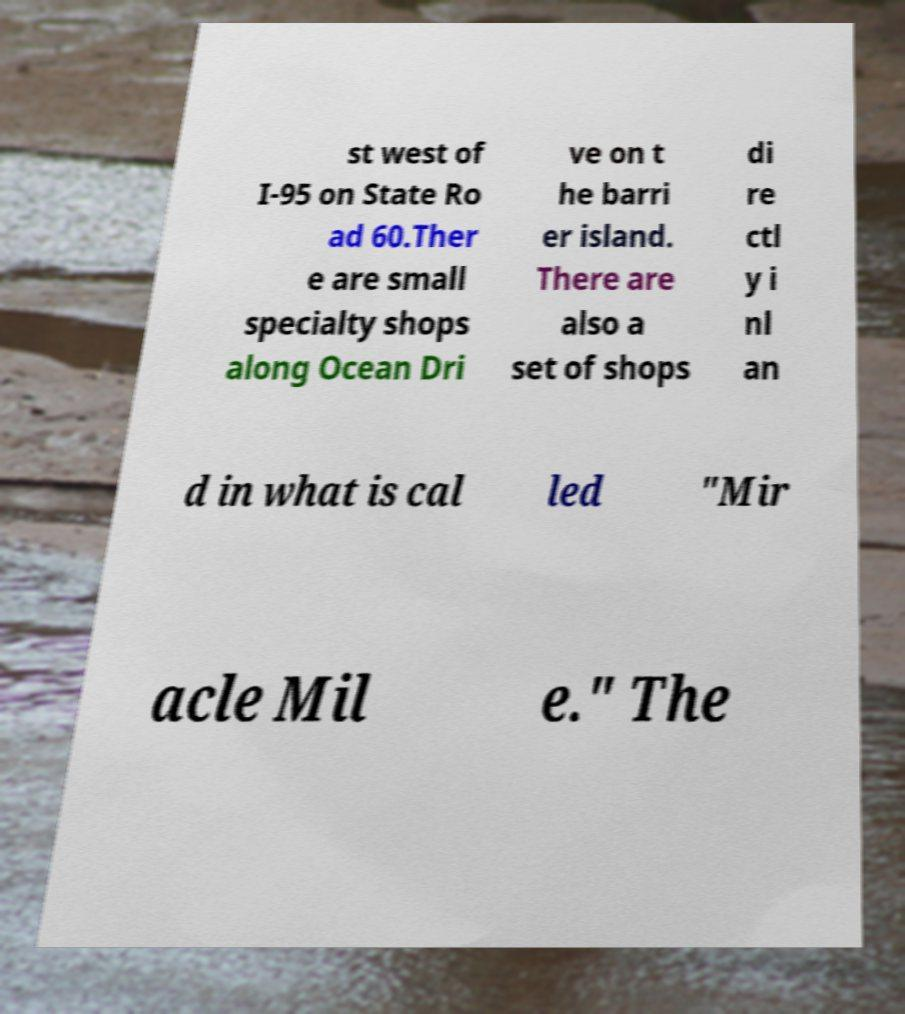What messages or text are displayed in this image? I need them in a readable, typed format. st west of I-95 on State Ro ad 60.Ther e are small specialty shops along Ocean Dri ve on t he barri er island. There are also a set of shops di re ctl y i nl an d in what is cal led "Mir acle Mil e." The 